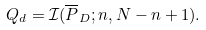<formula> <loc_0><loc_0><loc_500><loc_500>Q _ { d } = \mathcal { I } ( \overline { P } _ { D } ; n , N - n + 1 ) .</formula> 